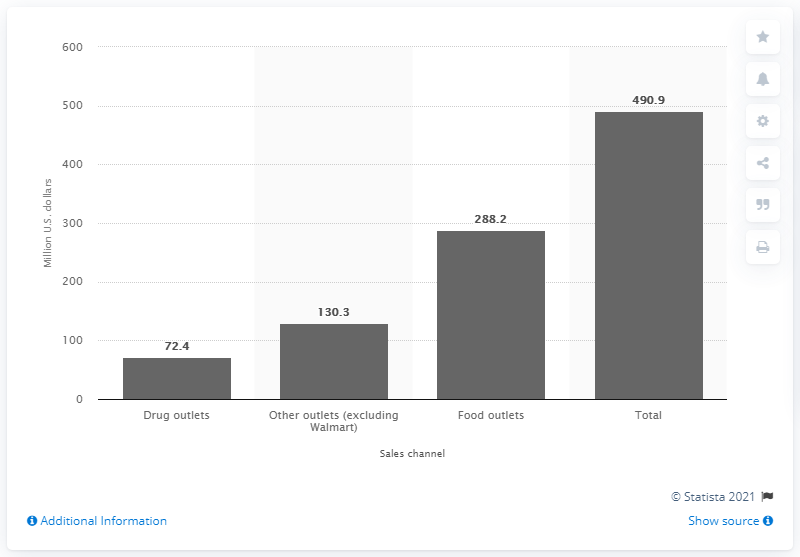List a handful of essential elements in this visual. In 2010 and 2011, a total of 72.4 million U.S. dollars were sold via drug outlets. In 2010 and 2011, the total sales of light bulbs in the United States were 490.9 million units. 